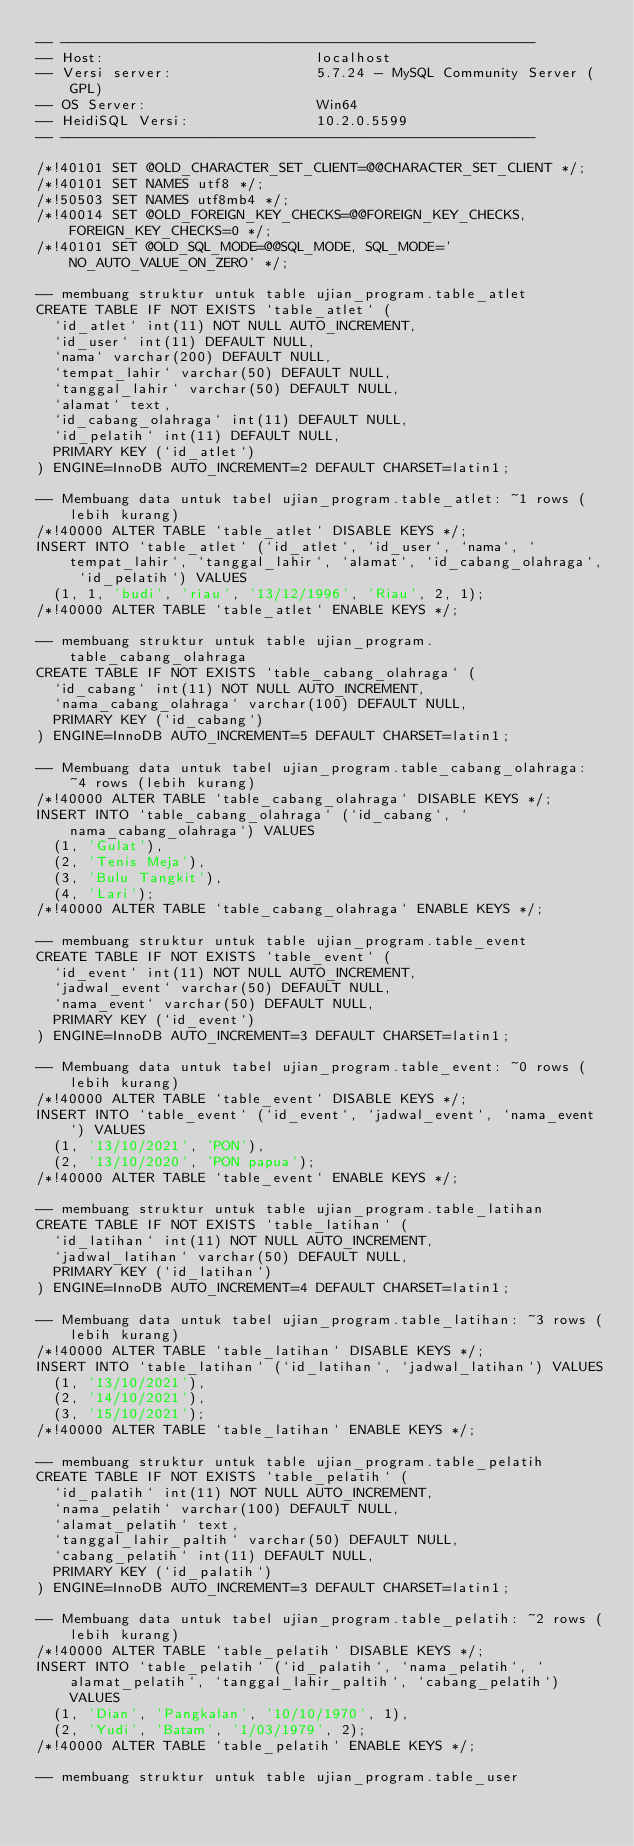Convert code to text. <code><loc_0><loc_0><loc_500><loc_500><_SQL_>-- --------------------------------------------------------
-- Host:                         localhost
-- Versi server:                 5.7.24 - MySQL Community Server (GPL)
-- OS Server:                    Win64
-- HeidiSQL Versi:               10.2.0.5599
-- --------------------------------------------------------

/*!40101 SET @OLD_CHARACTER_SET_CLIENT=@@CHARACTER_SET_CLIENT */;
/*!40101 SET NAMES utf8 */;
/*!50503 SET NAMES utf8mb4 */;
/*!40014 SET @OLD_FOREIGN_KEY_CHECKS=@@FOREIGN_KEY_CHECKS, FOREIGN_KEY_CHECKS=0 */;
/*!40101 SET @OLD_SQL_MODE=@@SQL_MODE, SQL_MODE='NO_AUTO_VALUE_ON_ZERO' */;

-- membuang struktur untuk table ujian_program.table_atlet
CREATE TABLE IF NOT EXISTS `table_atlet` (
  `id_atlet` int(11) NOT NULL AUTO_INCREMENT,
  `id_user` int(11) DEFAULT NULL,
  `nama` varchar(200) DEFAULT NULL,
  `tempat_lahir` varchar(50) DEFAULT NULL,
  `tanggal_lahir` varchar(50) DEFAULT NULL,
  `alamat` text,
  `id_cabang_olahraga` int(11) DEFAULT NULL,
  `id_pelatih` int(11) DEFAULT NULL,
  PRIMARY KEY (`id_atlet`)
) ENGINE=InnoDB AUTO_INCREMENT=2 DEFAULT CHARSET=latin1;

-- Membuang data untuk tabel ujian_program.table_atlet: ~1 rows (lebih kurang)
/*!40000 ALTER TABLE `table_atlet` DISABLE KEYS */;
INSERT INTO `table_atlet` (`id_atlet`, `id_user`, `nama`, `tempat_lahir`, `tanggal_lahir`, `alamat`, `id_cabang_olahraga`, `id_pelatih`) VALUES
	(1, 1, 'budi', 'riau', '13/12/1996', 'Riau', 2, 1);
/*!40000 ALTER TABLE `table_atlet` ENABLE KEYS */;

-- membuang struktur untuk table ujian_program.table_cabang_olahraga
CREATE TABLE IF NOT EXISTS `table_cabang_olahraga` (
  `id_cabang` int(11) NOT NULL AUTO_INCREMENT,
  `nama_cabang_olahraga` varchar(100) DEFAULT NULL,
  PRIMARY KEY (`id_cabang`)
) ENGINE=InnoDB AUTO_INCREMENT=5 DEFAULT CHARSET=latin1;

-- Membuang data untuk tabel ujian_program.table_cabang_olahraga: ~4 rows (lebih kurang)
/*!40000 ALTER TABLE `table_cabang_olahraga` DISABLE KEYS */;
INSERT INTO `table_cabang_olahraga` (`id_cabang`, `nama_cabang_olahraga`) VALUES
	(1, 'Gulat'),
	(2, 'Tenis Meja'),
	(3, 'Bulu Tangkit'),
	(4, 'Lari');
/*!40000 ALTER TABLE `table_cabang_olahraga` ENABLE KEYS */;

-- membuang struktur untuk table ujian_program.table_event
CREATE TABLE IF NOT EXISTS `table_event` (
  `id_event` int(11) NOT NULL AUTO_INCREMENT,
  `jadwal_event` varchar(50) DEFAULT NULL,
  `nama_event` varchar(50) DEFAULT NULL,
  PRIMARY KEY (`id_event`)
) ENGINE=InnoDB AUTO_INCREMENT=3 DEFAULT CHARSET=latin1;

-- Membuang data untuk tabel ujian_program.table_event: ~0 rows (lebih kurang)
/*!40000 ALTER TABLE `table_event` DISABLE KEYS */;
INSERT INTO `table_event` (`id_event`, `jadwal_event`, `nama_event`) VALUES
	(1, '13/10/2021', 'PON'),
	(2, '13/10/2020', 'PON papua');
/*!40000 ALTER TABLE `table_event` ENABLE KEYS */;

-- membuang struktur untuk table ujian_program.table_latihan
CREATE TABLE IF NOT EXISTS `table_latihan` (
  `id_latihan` int(11) NOT NULL AUTO_INCREMENT,
  `jadwal_latihan` varchar(50) DEFAULT NULL,
  PRIMARY KEY (`id_latihan`)
) ENGINE=InnoDB AUTO_INCREMENT=4 DEFAULT CHARSET=latin1;

-- Membuang data untuk tabel ujian_program.table_latihan: ~3 rows (lebih kurang)
/*!40000 ALTER TABLE `table_latihan` DISABLE KEYS */;
INSERT INTO `table_latihan` (`id_latihan`, `jadwal_latihan`) VALUES
	(1, '13/10/2021'),
	(2, '14/10/2021'),
	(3, '15/10/2021');
/*!40000 ALTER TABLE `table_latihan` ENABLE KEYS */;

-- membuang struktur untuk table ujian_program.table_pelatih
CREATE TABLE IF NOT EXISTS `table_pelatih` (
  `id_palatih` int(11) NOT NULL AUTO_INCREMENT,
  `nama_pelatih` varchar(100) DEFAULT NULL,
  `alamat_pelatih` text,
  `tanggal_lahir_paltih` varchar(50) DEFAULT NULL,
  `cabang_pelatih` int(11) DEFAULT NULL,
  PRIMARY KEY (`id_palatih`)
) ENGINE=InnoDB AUTO_INCREMENT=3 DEFAULT CHARSET=latin1;

-- Membuang data untuk tabel ujian_program.table_pelatih: ~2 rows (lebih kurang)
/*!40000 ALTER TABLE `table_pelatih` DISABLE KEYS */;
INSERT INTO `table_pelatih` (`id_palatih`, `nama_pelatih`, `alamat_pelatih`, `tanggal_lahir_paltih`, `cabang_pelatih`) VALUES
	(1, 'Dian', 'Pangkalan', '10/10/1970', 1),
	(2, 'Yudi', 'Batam', '1/03/1979', 2);
/*!40000 ALTER TABLE `table_pelatih` ENABLE KEYS */;

-- membuang struktur untuk table ujian_program.table_user</code> 